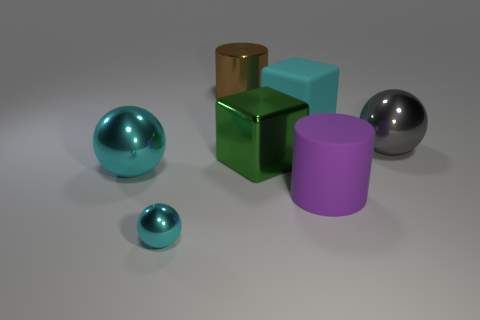Is the material of the big purple cylinder the same as the green block?
Give a very brief answer. No. There is a cyan matte object that is the same size as the green shiny thing; what shape is it?
Provide a short and direct response. Cube. Is the number of cyan cubes greater than the number of metal objects?
Provide a short and direct response. No. There is a big object that is both to the left of the large green cube and in front of the brown shiny object; what is its material?
Your response must be concise. Metal. How many other things are there of the same material as the cyan block?
Offer a very short reply. 1. How many balls have the same color as the tiny object?
Your answer should be compact. 1. How big is the cyan cube that is behind the large sphere on the right side of the big cylinder on the left side of the cyan rubber thing?
Your response must be concise. Large. What number of metal objects are either large objects or red spheres?
Provide a short and direct response. 4. There is a purple matte thing; is its shape the same as the cyan object that is right of the small cyan object?
Give a very brief answer. No. Are there more purple matte things that are behind the big shiny cube than big brown cylinders right of the purple matte thing?
Ensure brevity in your answer.  No. 